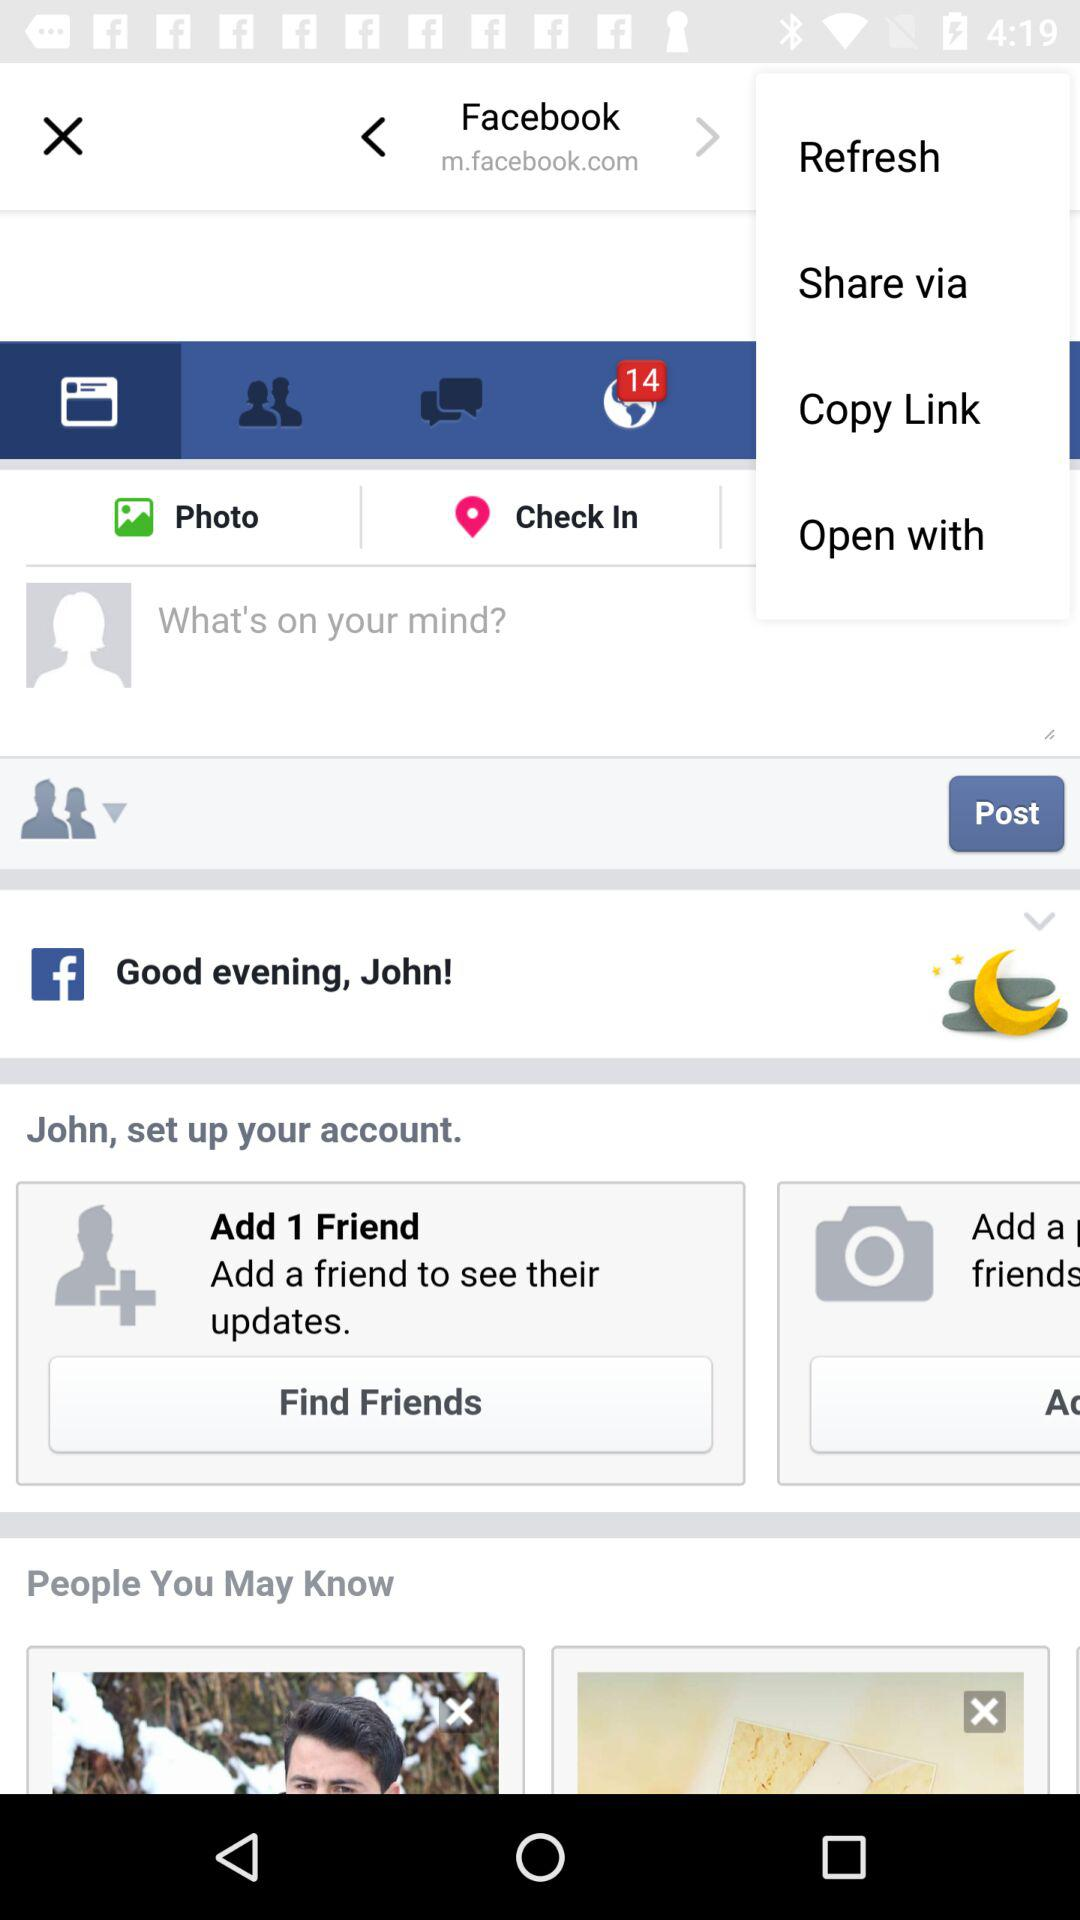What is the name of the application? The name of the application is "Facebook". 